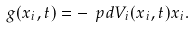<formula> <loc_0><loc_0><loc_500><loc_500>g ( x _ { i } , t ) = - \ p d { V _ { i } ( x _ { i } , t ) } { x _ { i } } .</formula> 